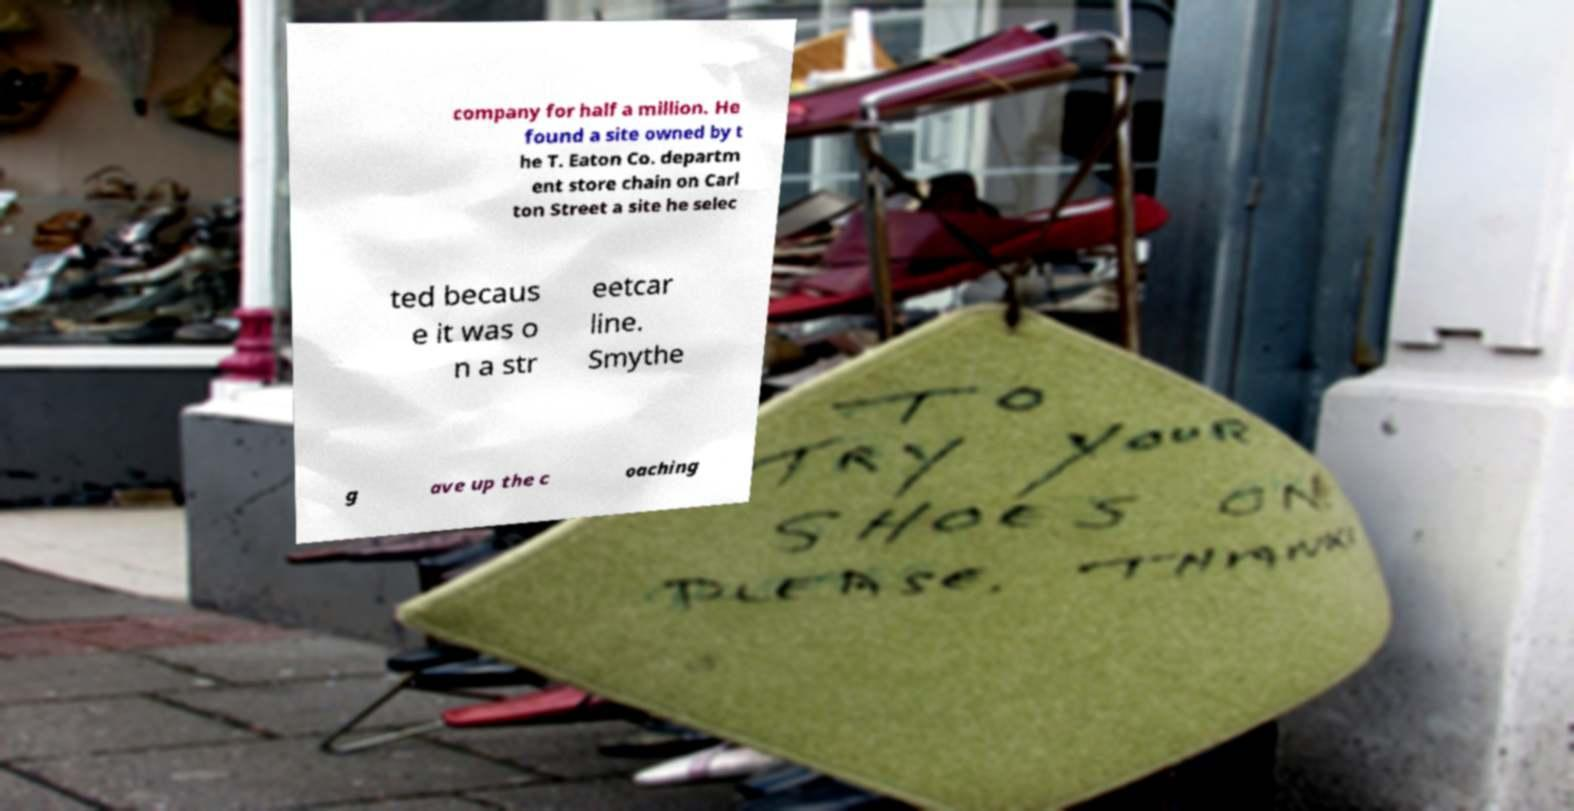There's text embedded in this image that I need extracted. Can you transcribe it verbatim? company for half a million. He found a site owned by t he T. Eaton Co. departm ent store chain on Carl ton Street a site he selec ted becaus e it was o n a str eetcar line. Smythe g ave up the c oaching 